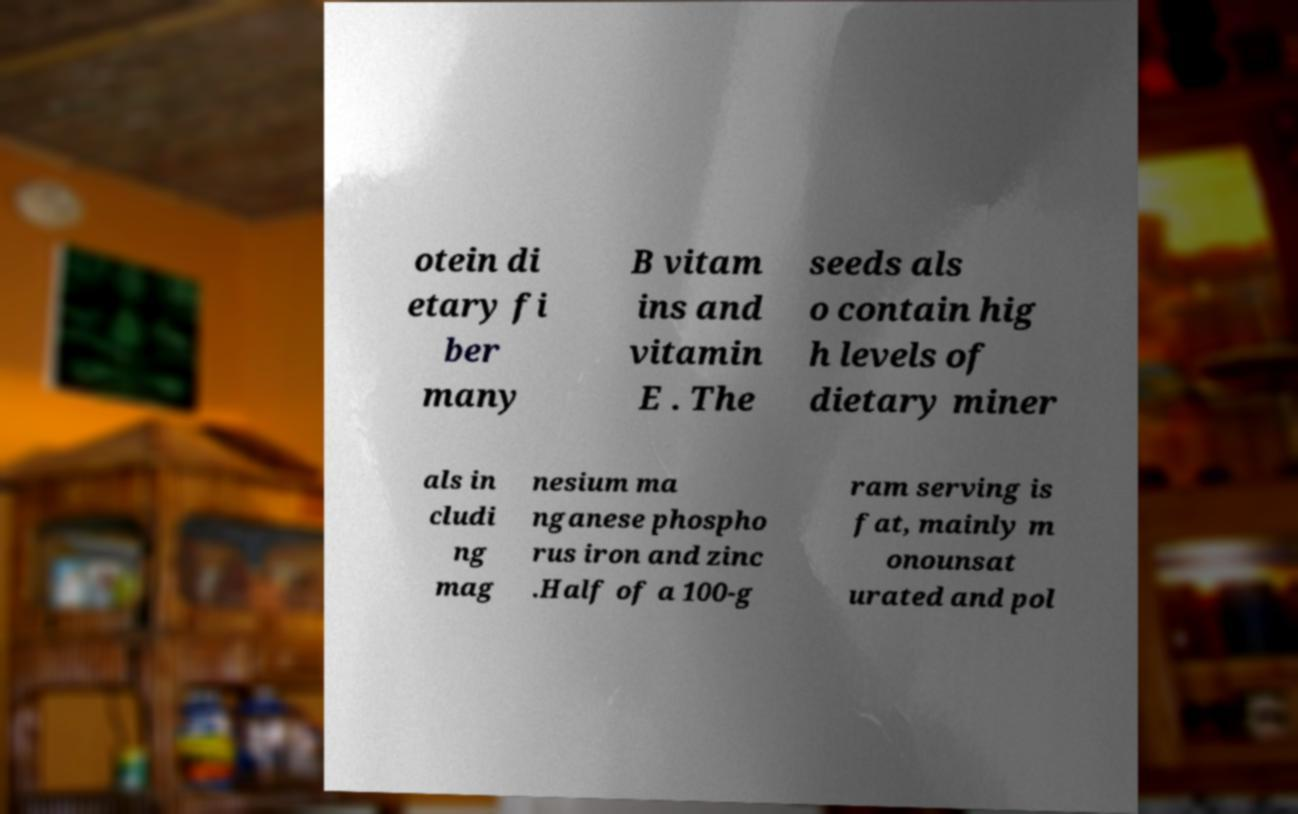I need the written content from this picture converted into text. Can you do that? otein di etary fi ber many B vitam ins and vitamin E . The seeds als o contain hig h levels of dietary miner als in cludi ng mag nesium ma nganese phospho rus iron and zinc .Half of a 100-g ram serving is fat, mainly m onounsat urated and pol 